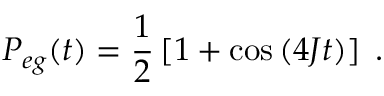Convert formula to latex. <formula><loc_0><loc_0><loc_500><loc_500>P _ { e g } ( t ) = \frac { 1 } { 2 } \left [ 1 + \cos \left ( 4 J t \right ) \right ] \, .</formula> 